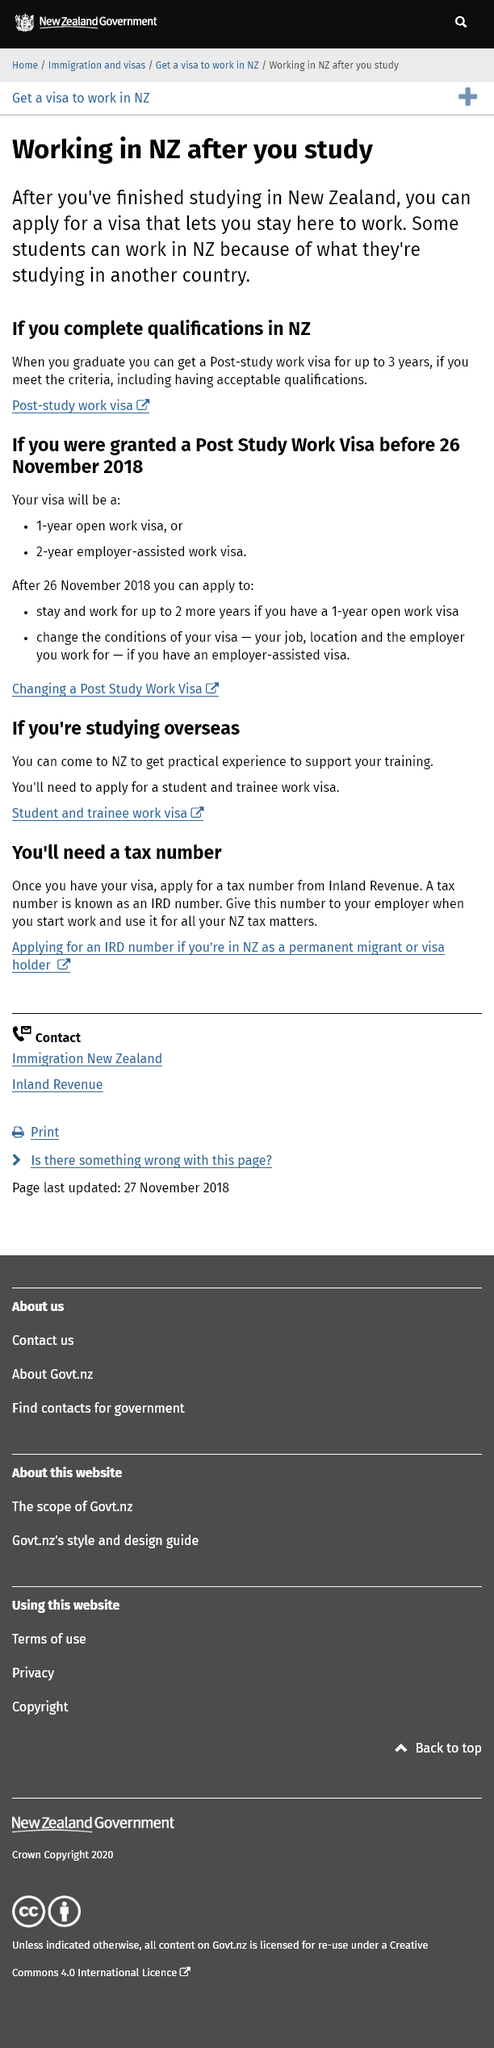Indicate a few pertinent items in this graphic. The visa allows for the ability to stay in New Zealand after completing studies to pursue employment. The duration of a post-study work visa can be up to 3 years, provided that the individual meets the necessary criteria. If you want to work in New Zealand after you complete your studies, you can apply for a visa that allows you to stay and work in the country. 